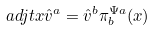Convert formula to latex. <formula><loc_0><loc_0><loc_500><loc_500>\ a d j t { x } \hat { v } ^ { a } = \hat { v } ^ { b } \pi _ { b } ^ { \Psi a } ( x )</formula> 